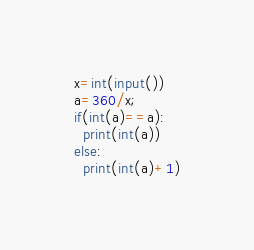<code> <loc_0><loc_0><loc_500><loc_500><_Python_>x=int(input())
a=360/x;
if(int(a)==a):
  print(int(a))
else:
  print(int(a)+1)

</code> 